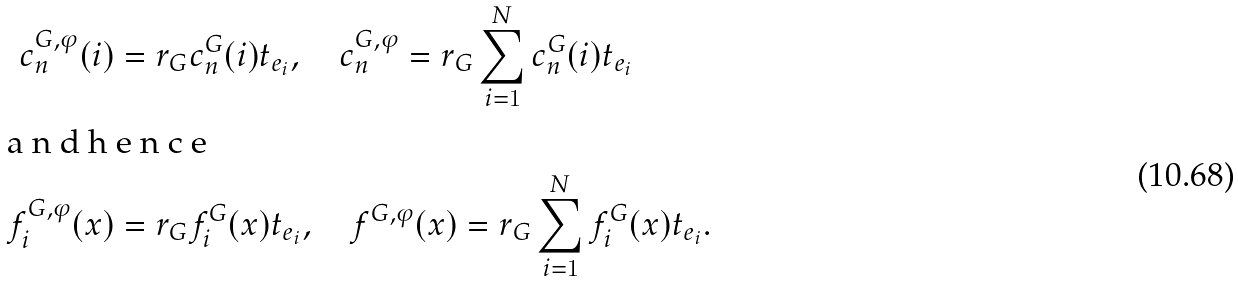Convert formula to latex. <formula><loc_0><loc_0><loc_500><loc_500>c ^ { G , \varphi } _ { n } ( i ) & = r _ { G } c ^ { G } _ { n } ( i ) t _ { e _ { i } } , \quad c ^ { G , \varphi } _ { n } = r _ { G } \sum _ { i = 1 } ^ { N } c ^ { G } _ { n } ( i ) t _ { e _ { i } } \\ \intertext { a n d h e n c e } f ^ { G , \varphi } _ { i } ( x ) & = r _ { G } f ^ { G } _ { i } ( x ) t _ { e _ { i } } , \quad f ^ { G , \varphi } ( x ) = r _ { G } \sum _ { i = 1 } ^ { N } f ^ { G } _ { i } ( x ) t _ { e _ { i } } .</formula> 